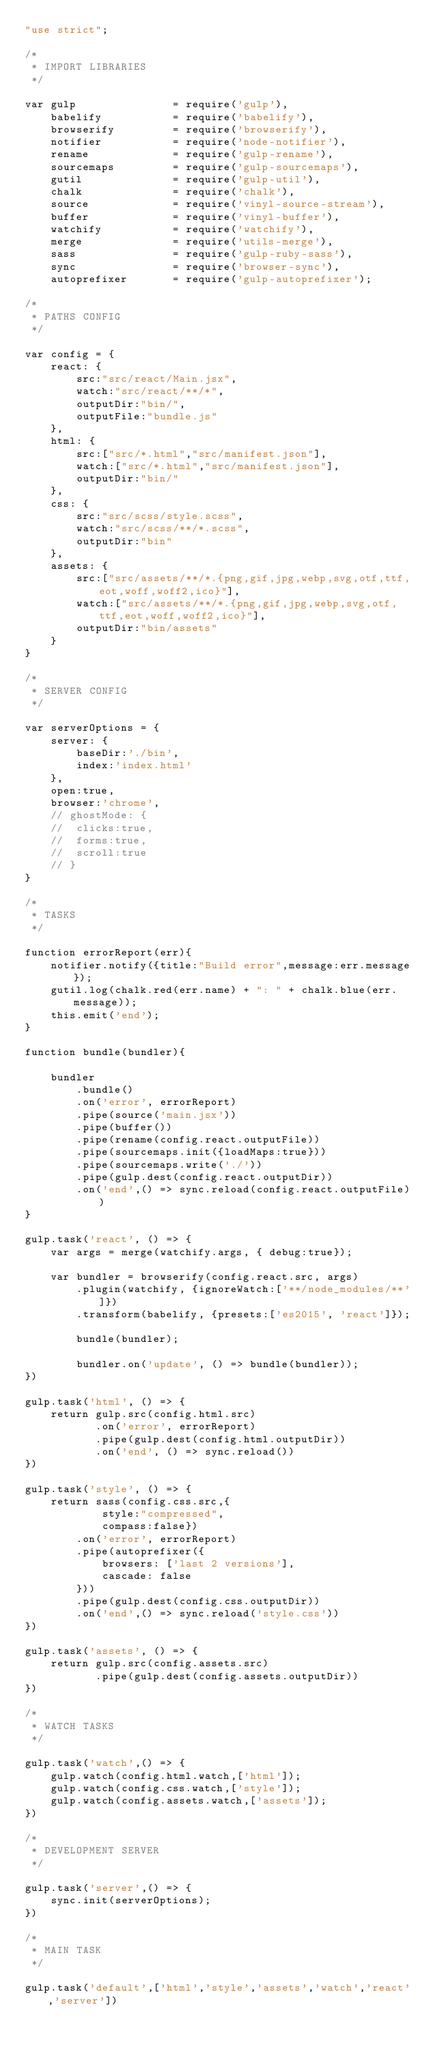<code> <loc_0><loc_0><loc_500><loc_500><_JavaScript_>"use strict";

/*
 * IMPORT LIBRARIES
 */

var gulp               = require('gulp'),
	babelify           = require('babelify'),
	browserify         = require('browserify'),
	notifier           = require('node-notifier'),
	rename             = require('gulp-rename'),
	sourcemaps         = require('gulp-sourcemaps'),
	gutil              = require('gulp-util'),
	chalk              = require('chalk'),
	source             = require('vinyl-source-stream'),
	buffer             = require('vinyl-buffer'),
	watchify           = require('watchify'),
	merge              = require('utils-merge'),
	sass               = require('gulp-ruby-sass'),
	sync               = require('browser-sync'),
	autoprefixer       = require('gulp-autoprefixer');

/*
 * PATHS CONFIG
 */

var config = {
	react: {
		src:"src/react/Main.jsx",
		watch:"src/react/**/*",
		outputDir:"bin/",
		outputFile:"bundle.js"
	},
	html: {
		src:["src/*.html","src/manifest.json"],
		watch:["src/*.html","src/manifest.json"],
		outputDir:"bin/"
	},
	css: {
		src:"src/scss/style.scss",
		watch:"src/scss/**/*.scss",
		outputDir:"bin"
	},
	assets: {
		src:["src/assets/**/*.{png,gif,jpg,webp,svg,otf,ttf,eot,woff,woff2,ico}"],
		watch:["src/assets/**/*.{png,gif,jpg,webp,svg,otf,ttf,eot,woff,woff2,ico}"],
		outputDir:"bin/assets"
	}
}

/*
 * SERVER CONFIG
 */

var serverOptions = {
	server: {
		baseDir:'./bin',
		index:'index.html'
	},
	open:true,
	browser:'chrome',
	// ghostMode: {
	// 	clicks:true,
	// 	forms:true,
	// 	scroll:true
	// }
}

/*
 * TASKS
 */

function errorReport(err){
	notifier.notify({title:"Build error",message:err.message});
	gutil.log(chalk.red(err.name) + ": " + chalk.blue(err.message));
	this.emit('end');
}

function bundle(bundler){

	bundler
		.bundle()
		.on('error', errorReport)
		.pipe(source('main.jsx'))
		.pipe(buffer())
		.pipe(rename(config.react.outputFile))
		.pipe(sourcemaps.init({loadMaps:true}))
		.pipe(sourcemaps.write('./'))
		.pipe(gulp.dest(config.react.outputDir))
		.on('end',() => sync.reload(config.react.outputFile))
}

gulp.task('react', () => {
	var args = merge(watchify.args, { debug:true});

	var bundler = browserify(config.react.src, args)
		.plugin(watchify, {ignoreWatch:['**/node_modules/**']})
		.transform(babelify, {presets:['es2015', 'react']});

		bundle(bundler);

		bundler.on('update', () => bundle(bundler));
})

gulp.task('html', () => {
	return gulp.src(config.html.src)
		   .on('error', errorReport)
		   .pipe(gulp.dest(config.html.outputDir))
		   .on('end', () => sync.reload())
})

gulp.task('style', () => {
	return sass(config.css.src,{
			style:"compressed",
			compass:false})
		.on('error', errorReport)
		.pipe(autoprefixer({
			browsers: ['last 2 versions'],
			cascade: false
		}))
		.pipe(gulp.dest(config.css.outputDir))
		.on('end',() => sync.reload('style.css'))
})

gulp.task('assets', () => {
	return gulp.src(config.assets.src)
		   .pipe(gulp.dest(config.assets.outputDir))
})

/*
 * WATCH TASKS
 */

gulp.task('watch',() => {
	gulp.watch(config.html.watch,['html']);
	gulp.watch(config.css.watch,['style']);
	gulp.watch(config.assets.watch,['assets']);
})

/*
 * DEVELOPMENT SERVER
 */

gulp.task('server',() => {
	sync.init(serverOptions);
})

/*
 * MAIN TASK
 */

gulp.task('default',['html','style','assets','watch','react','server'])

</code> 